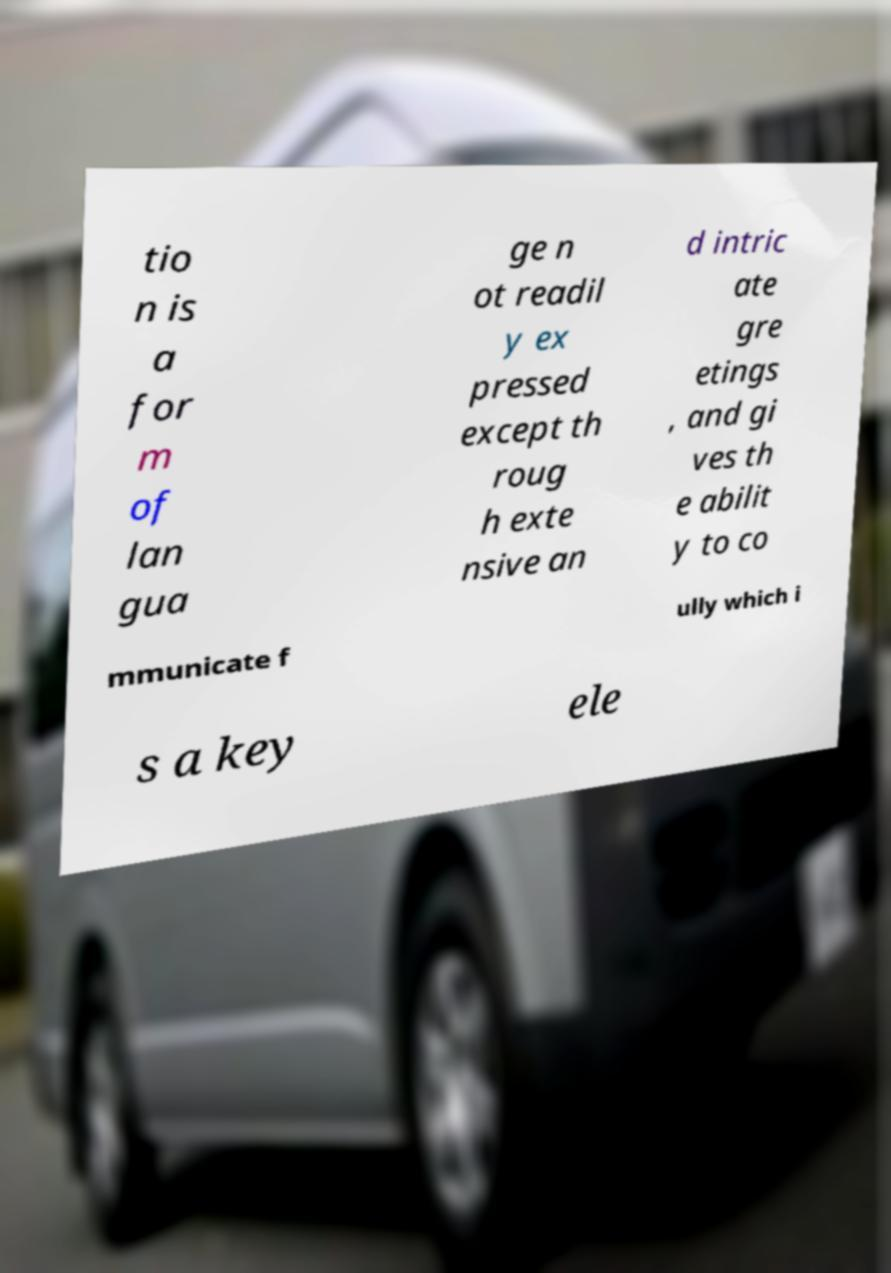There's text embedded in this image that I need extracted. Can you transcribe it verbatim? tio n is a for m of lan gua ge n ot readil y ex pressed except th roug h exte nsive an d intric ate gre etings , and gi ves th e abilit y to co mmunicate f ully which i s a key ele 